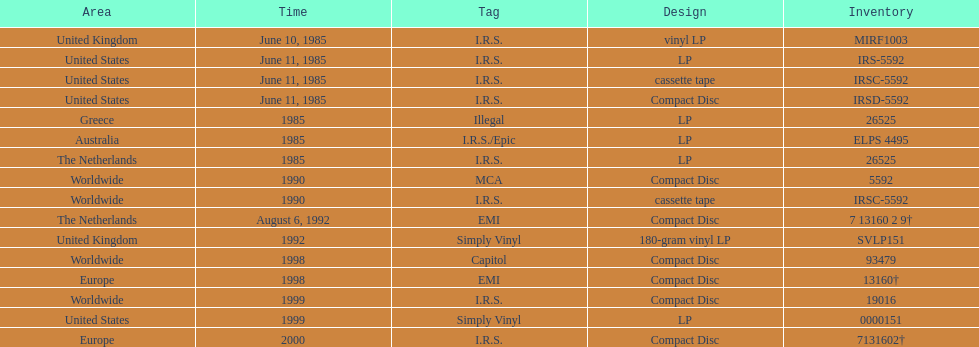What is the quantity of releases in compact disc format exceeding those in cassette tape? 5. Can you parse all the data within this table? {'header': ['Area', 'Time', 'Tag', 'Design', 'Inventory'], 'rows': [['United Kingdom', 'June 10, 1985', 'I.R.S.', 'vinyl LP', 'MIRF1003'], ['United States', 'June 11, 1985', 'I.R.S.', 'LP', 'IRS-5592'], ['United States', 'June 11, 1985', 'I.R.S.', 'cassette tape', 'IRSC-5592'], ['United States', 'June 11, 1985', 'I.R.S.', 'Compact Disc', 'IRSD-5592'], ['Greece', '1985', 'Illegal', 'LP', '26525'], ['Australia', '1985', 'I.R.S./Epic', 'LP', 'ELPS 4495'], ['The Netherlands', '1985', 'I.R.S.', 'LP', '26525'], ['Worldwide', '1990', 'MCA', 'Compact Disc', '5592'], ['Worldwide', '1990', 'I.R.S.', 'cassette tape', 'IRSC-5592'], ['The Netherlands', 'August 6, 1992', 'EMI', 'Compact Disc', '7 13160 2 9†'], ['United Kingdom', '1992', 'Simply Vinyl', '180-gram vinyl LP', 'SVLP151'], ['Worldwide', '1998', 'Capitol', 'Compact Disc', '93479'], ['Europe', '1998', 'EMI', 'Compact Disc', '13160†'], ['Worldwide', '1999', 'I.R.S.', 'Compact Disc', '19016'], ['United States', '1999', 'Simply Vinyl', 'LP', '0000151'], ['Europe', '2000', 'I.R.S.', 'Compact Disc', '7131602†']]} 